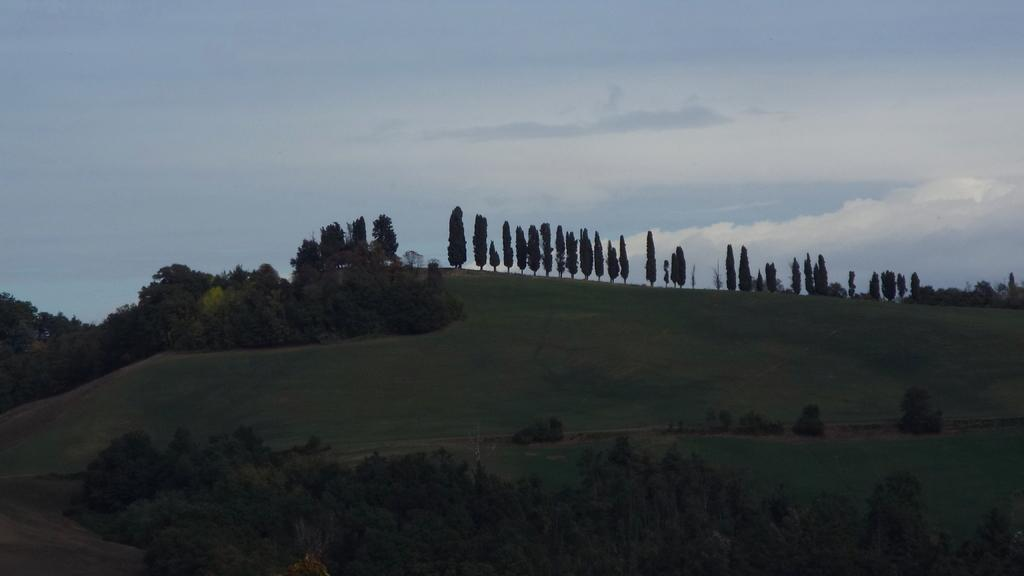What type of vegetation can be seen in the image? There are many trees and plants on the ground in the image. What can be seen in the background of the image? There are clouds and the sky visible in the background of the image. What type of mine is visible in the image? There is no mine present in the image; it features trees, plants, clouds, and the sky. How many wrens can be seen in the image? There are no wrens present in the image. 